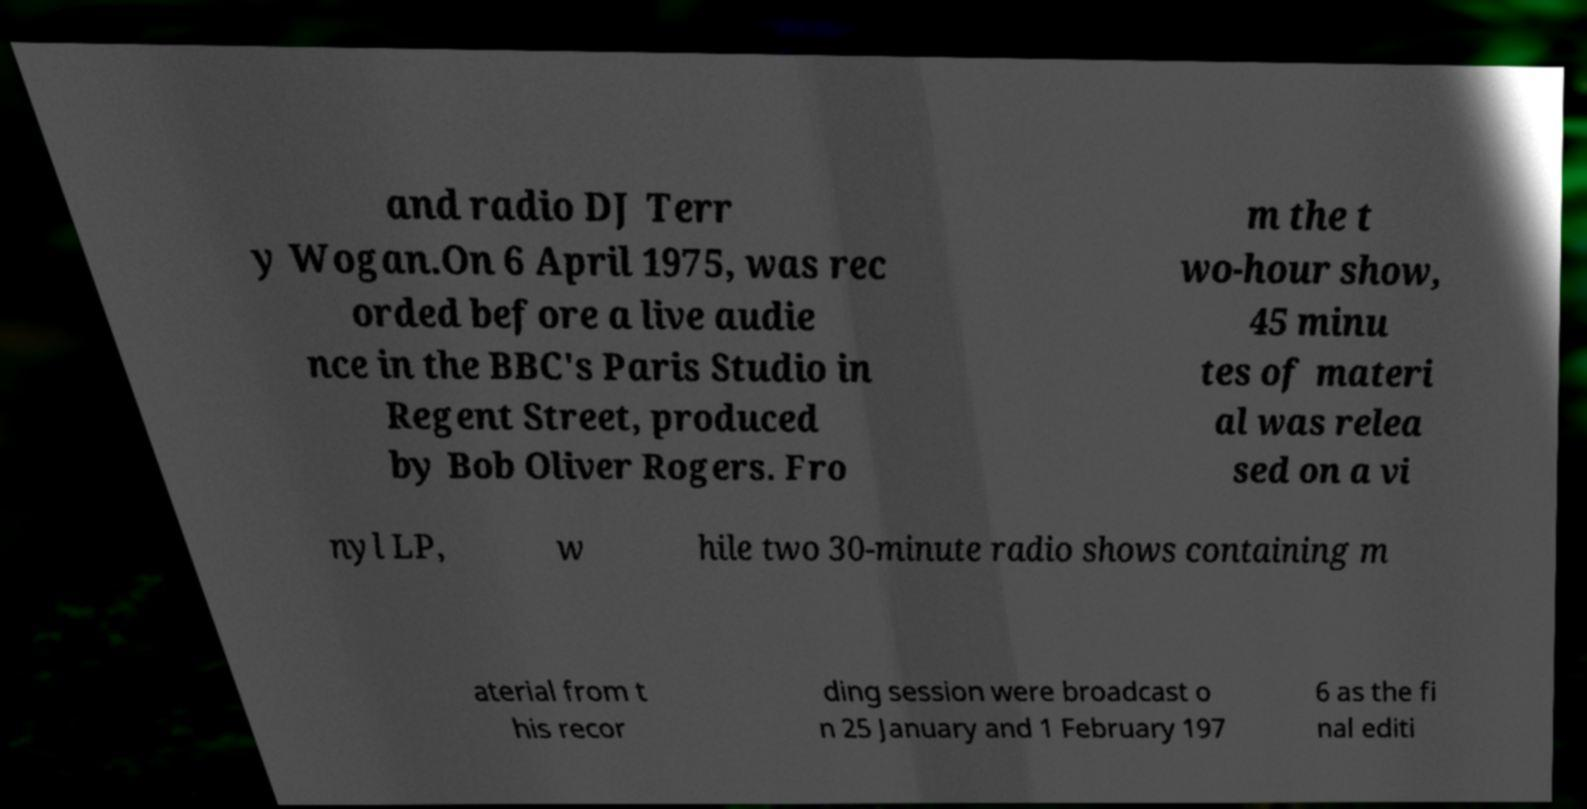For documentation purposes, I need the text within this image transcribed. Could you provide that? and radio DJ Terr y Wogan.On 6 April 1975, was rec orded before a live audie nce in the BBC's Paris Studio in Regent Street, produced by Bob Oliver Rogers. Fro m the t wo-hour show, 45 minu tes of materi al was relea sed on a vi nyl LP, w hile two 30-minute radio shows containing m aterial from t his recor ding session were broadcast o n 25 January and 1 February 197 6 as the fi nal editi 